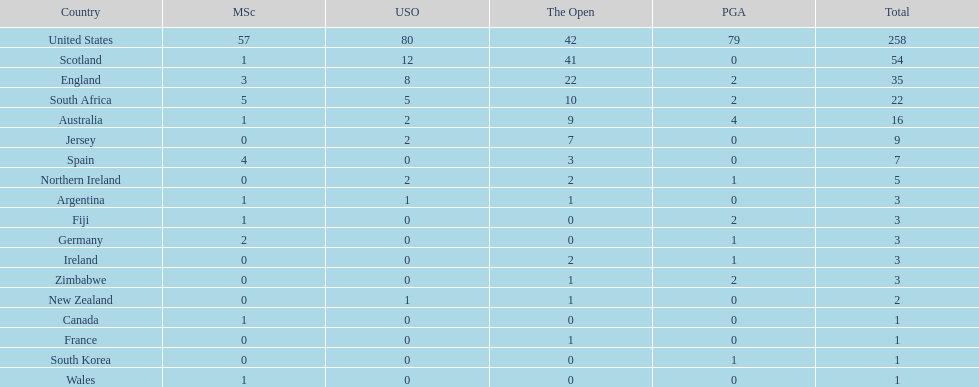How many u.s. open wins does fiji have? 0. 